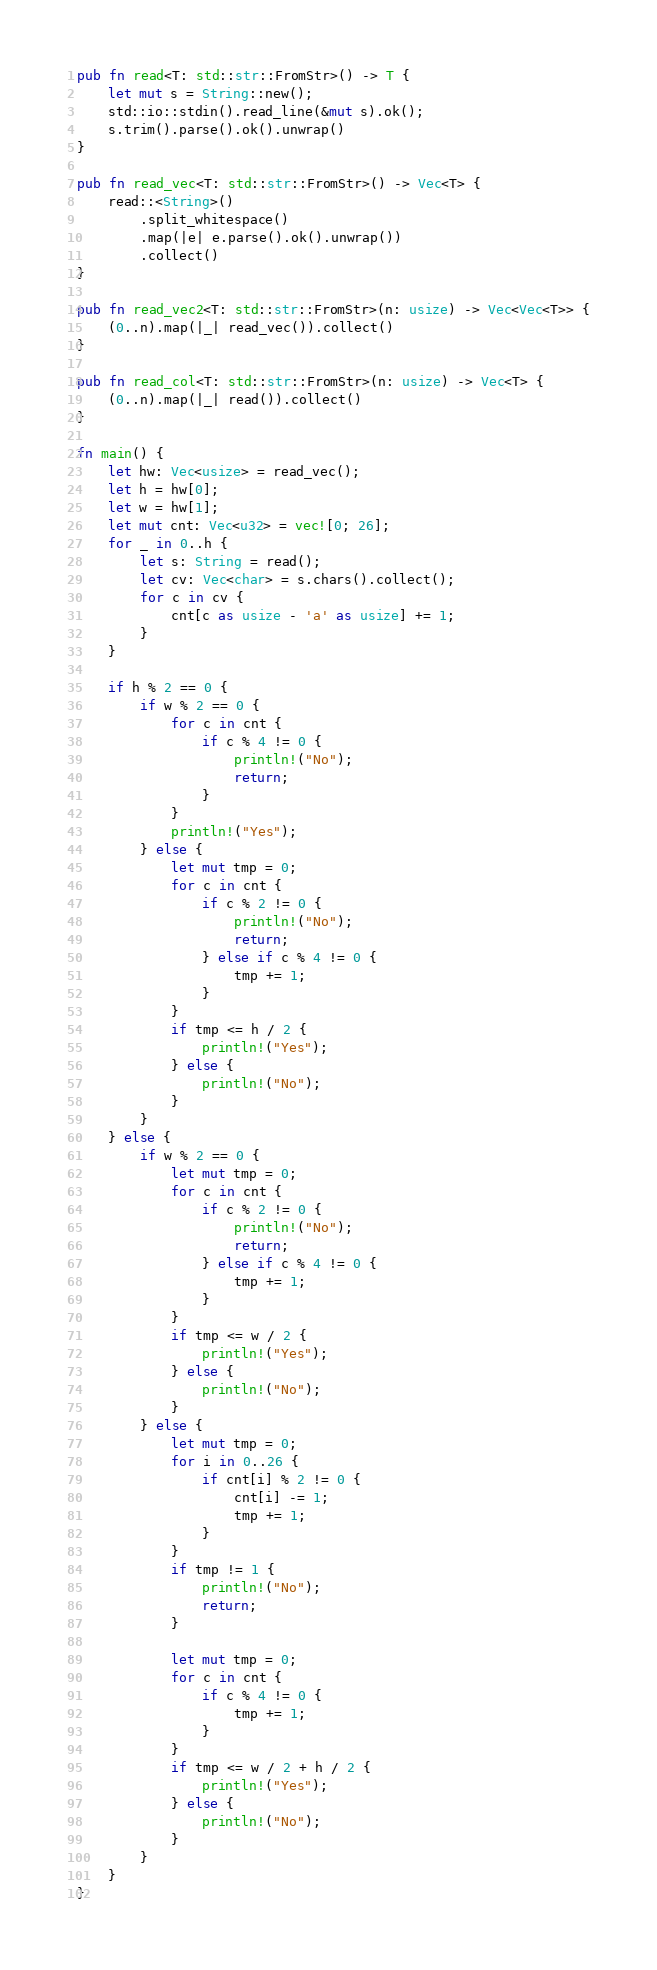<code> <loc_0><loc_0><loc_500><loc_500><_Rust_>pub fn read<T: std::str::FromStr>() -> T {
    let mut s = String::new();
    std::io::stdin().read_line(&mut s).ok();
    s.trim().parse().ok().unwrap()
}

pub fn read_vec<T: std::str::FromStr>() -> Vec<T> {
    read::<String>()
        .split_whitespace()
        .map(|e| e.parse().ok().unwrap())
        .collect()
}

pub fn read_vec2<T: std::str::FromStr>(n: usize) -> Vec<Vec<T>> {
    (0..n).map(|_| read_vec()).collect()
}

pub fn read_col<T: std::str::FromStr>(n: usize) -> Vec<T> {
    (0..n).map(|_| read()).collect()
}

fn main() {
    let hw: Vec<usize> = read_vec();
    let h = hw[0];
    let w = hw[1];
    let mut cnt: Vec<u32> = vec![0; 26];
    for _ in 0..h {
        let s: String = read();
        let cv: Vec<char> = s.chars().collect();
        for c in cv {
            cnt[c as usize - 'a' as usize] += 1;
        }
    }

    if h % 2 == 0 {
        if w % 2 == 0 {
            for c in cnt {
                if c % 4 != 0 {
                    println!("No");
                    return;
                }
            }
            println!("Yes");
        } else {
            let mut tmp = 0;
            for c in cnt {
                if c % 2 != 0 {
                    println!("No");
                    return;
                } else if c % 4 != 0 {
                    tmp += 1;
                }
            }
            if tmp <= h / 2 {
                println!("Yes");
            } else {
                println!("No");
            }
        }
    } else {
        if w % 2 == 0 {
            let mut tmp = 0;
            for c in cnt {
                if c % 2 != 0 {
                    println!("No");
                    return;
                } else if c % 4 != 0 {
                    tmp += 1;
                }
            }
            if tmp <= w / 2 {
                println!("Yes");
            } else {
                println!("No");
            }
        } else {
            let mut tmp = 0;
            for i in 0..26 {
                if cnt[i] % 2 != 0 {
                    cnt[i] -= 1;
                    tmp += 1;
                }
            }
            if tmp != 1 {
                println!("No");
                return;
            }

            let mut tmp = 0;
            for c in cnt {
                if c % 4 != 0 {
                    tmp += 1;
                }
            }
            if tmp <= w / 2 + h / 2 {
                println!("Yes");
            } else {
                println!("No");
            }
        }
    }
}
</code> 